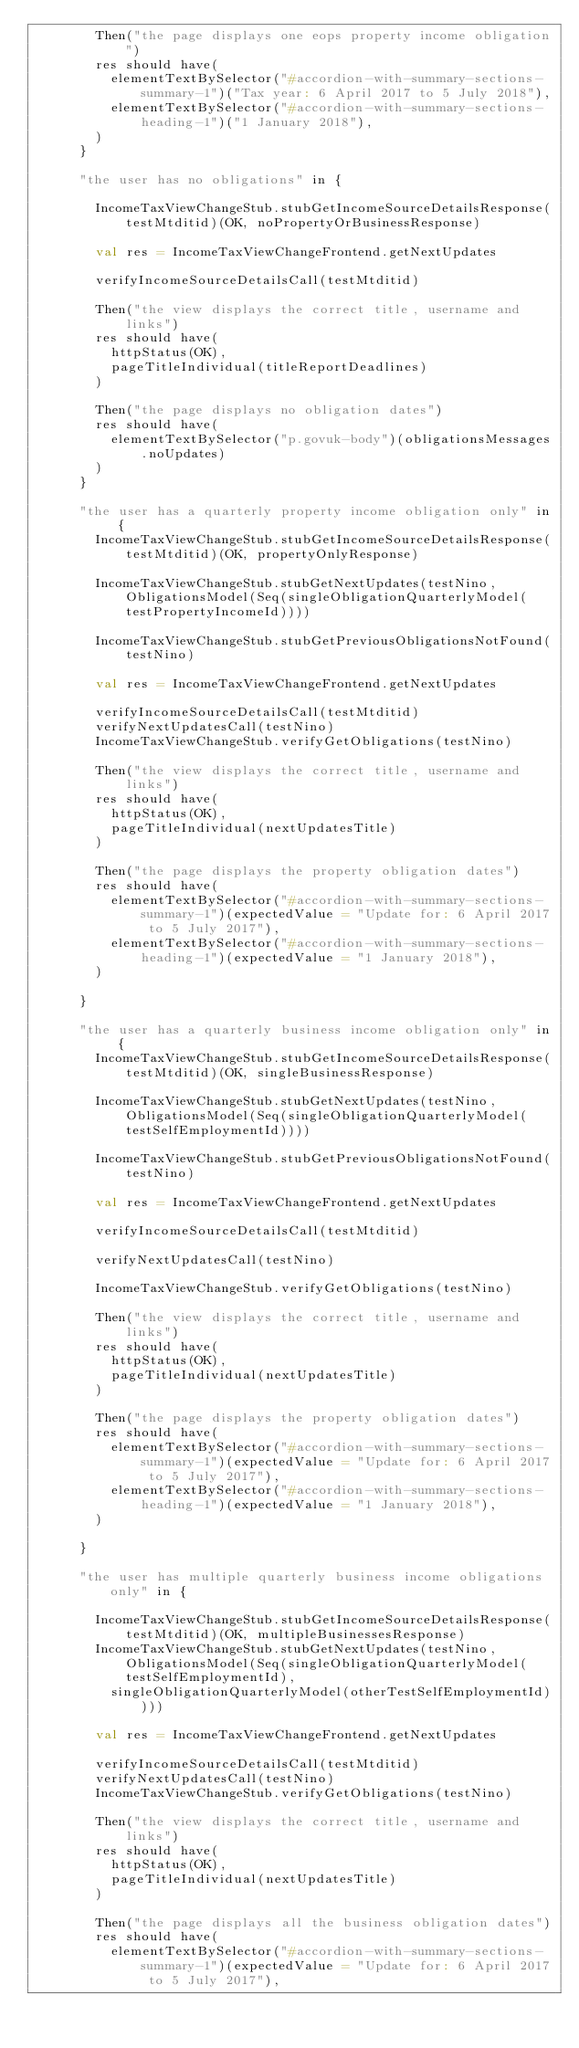Convert code to text. <code><loc_0><loc_0><loc_500><loc_500><_Scala_>        Then("the page displays one eops property income obligation")
        res should have(
          elementTextBySelector("#accordion-with-summary-sections-summary-1")("Tax year: 6 April 2017 to 5 July 2018"),
          elementTextBySelector("#accordion-with-summary-sections-heading-1")("1 January 2018"),
        )
      }

      "the user has no obligations" in {

        IncomeTaxViewChangeStub.stubGetIncomeSourceDetailsResponse(testMtditid)(OK, noPropertyOrBusinessResponse)

        val res = IncomeTaxViewChangeFrontend.getNextUpdates

        verifyIncomeSourceDetailsCall(testMtditid)

        Then("the view displays the correct title, username and links")
        res should have(
          httpStatus(OK),
          pageTitleIndividual(titleReportDeadlines)
        )

        Then("the page displays no obligation dates")
        res should have(
          elementTextBySelector("p.govuk-body")(obligationsMessages.noUpdates)
        )
      }

      "the user has a quarterly property income obligation only" in {
        IncomeTaxViewChangeStub.stubGetIncomeSourceDetailsResponse(testMtditid)(OK, propertyOnlyResponse)

        IncomeTaxViewChangeStub.stubGetNextUpdates(testNino, ObligationsModel(Seq(singleObligationQuarterlyModel(testPropertyIncomeId))))

        IncomeTaxViewChangeStub.stubGetPreviousObligationsNotFound(testNino)

        val res = IncomeTaxViewChangeFrontend.getNextUpdates

        verifyIncomeSourceDetailsCall(testMtditid)
        verifyNextUpdatesCall(testNino)
        IncomeTaxViewChangeStub.verifyGetObligations(testNino)

        Then("the view displays the correct title, username and links")
        res should have(
          httpStatus(OK),
          pageTitleIndividual(nextUpdatesTitle)
        )

        Then("the page displays the property obligation dates")
        res should have(
          elementTextBySelector("#accordion-with-summary-sections-summary-1")(expectedValue = "Update for: 6 April 2017 to 5 July 2017"),
          elementTextBySelector("#accordion-with-summary-sections-heading-1")(expectedValue = "1 January 2018"),
        )

      }

      "the user has a quarterly business income obligation only" in {
        IncomeTaxViewChangeStub.stubGetIncomeSourceDetailsResponse(testMtditid)(OK, singleBusinessResponse)

        IncomeTaxViewChangeStub.stubGetNextUpdates(testNino, ObligationsModel(Seq(singleObligationQuarterlyModel(testSelfEmploymentId))))

        IncomeTaxViewChangeStub.stubGetPreviousObligationsNotFound(testNino)

        val res = IncomeTaxViewChangeFrontend.getNextUpdates

        verifyIncomeSourceDetailsCall(testMtditid)

        verifyNextUpdatesCall(testNino)

        IncomeTaxViewChangeStub.verifyGetObligations(testNino)

        Then("the view displays the correct title, username and links")
        res should have(
          httpStatus(OK),
          pageTitleIndividual(nextUpdatesTitle)
        )

        Then("the page displays the property obligation dates")
        res should have(
          elementTextBySelector("#accordion-with-summary-sections-summary-1")(expectedValue = "Update for: 6 April 2017 to 5 July 2017"),
          elementTextBySelector("#accordion-with-summary-sections-heading-1")(expectedValue = "1 January 2018"),
        )

      }

      "the user has multiple quarterly business income obligations only" in {

        IncomeTaxViewChangeStub.stubGetIncomeSourceDetailsResponse(testMtditid)(OK, multipleBusinessesResponse)
        IncomeTaxViewChangeStub.stubGetNextUpdates(testNino, ObligationsModel(Seq(singleObligationQuarterlyModel(testSelfEmploymentId),
          singleObligationQuarterlyModel(otherTestSelfEmploymentId))))

        val res = IncomeTaxViewChangeFrontend.getNextUpdates

        verifyIncomeSourceDetailsCall(testMtditid)
        verifyNextUpdatesCall(testNino)
        IncomeTaxViewChangeStub.verifyGetObligations(testNino)

        Then("the view displays the correct title, username and links")
        res should have(
          httpStatus(OK),
          pageTitleIndividual(nextUpdatesTitle)
        )

        Then("the page displays all the business obligation dates")
        res should have(
          elementTextBySelector("#accordion-with-summary-sections-summary-1")(expectedValue = "Update for: 6 April 2017 to 5 July 2017"),</code> 